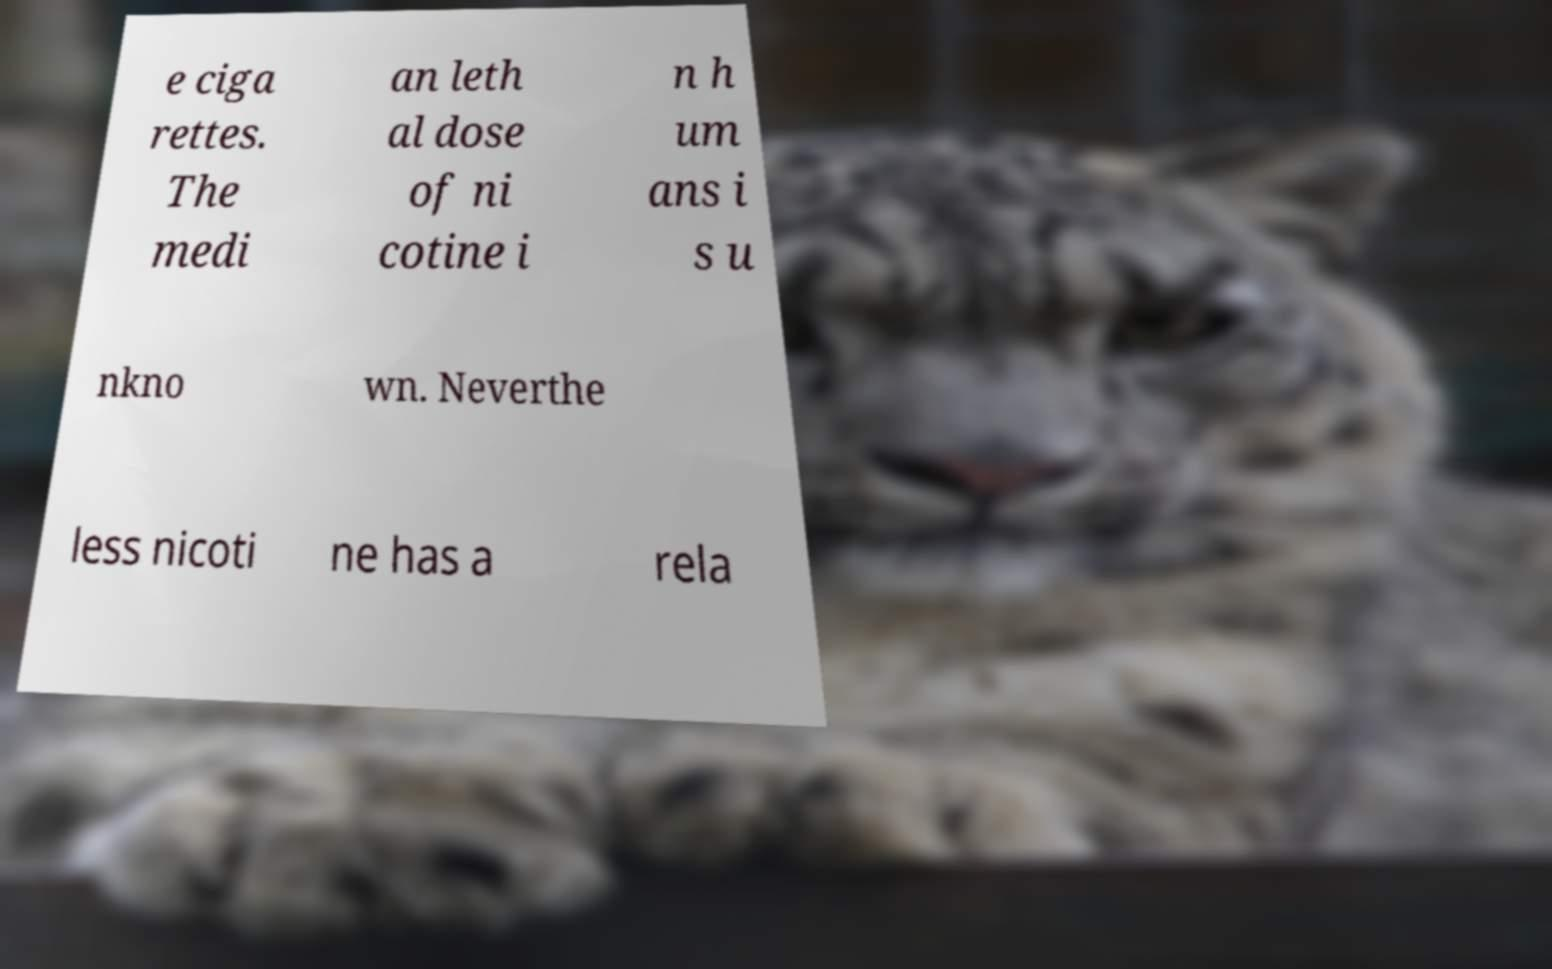There's text embedded in this image that I need extracted. Can you transcribe it verbatim? e ciga rettes. The medi an leth al dose of ni cotine i n h um ans i s u nkno wn. Neverthe less nicoti ne has a rela 